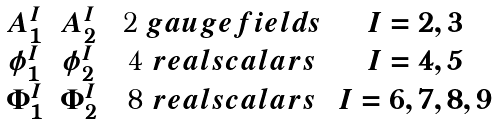<formula> <loc_0><loc_0><loc_500><loc_500>\begin{matrix} A ^ { I } _ { 1 } & A ^ { I } _ { 2 } & $ 2 $ g a u g e f i e l d s & I = 2 , 3 \\ \phi ^ { I } _ { 1 } & \phi ^ { I } _ { 2 } & $ 4 $ r e a l s c a l a r s & I = 4 , 5 \\ \Phi ^ { I } _ { 1 } & \Phi ^ { I } _ { 2 } & $ 8 $ r e a l s c a l a r s & I = 6 , 7 , 8 , 9 \\ \end{matrix}</formula> 